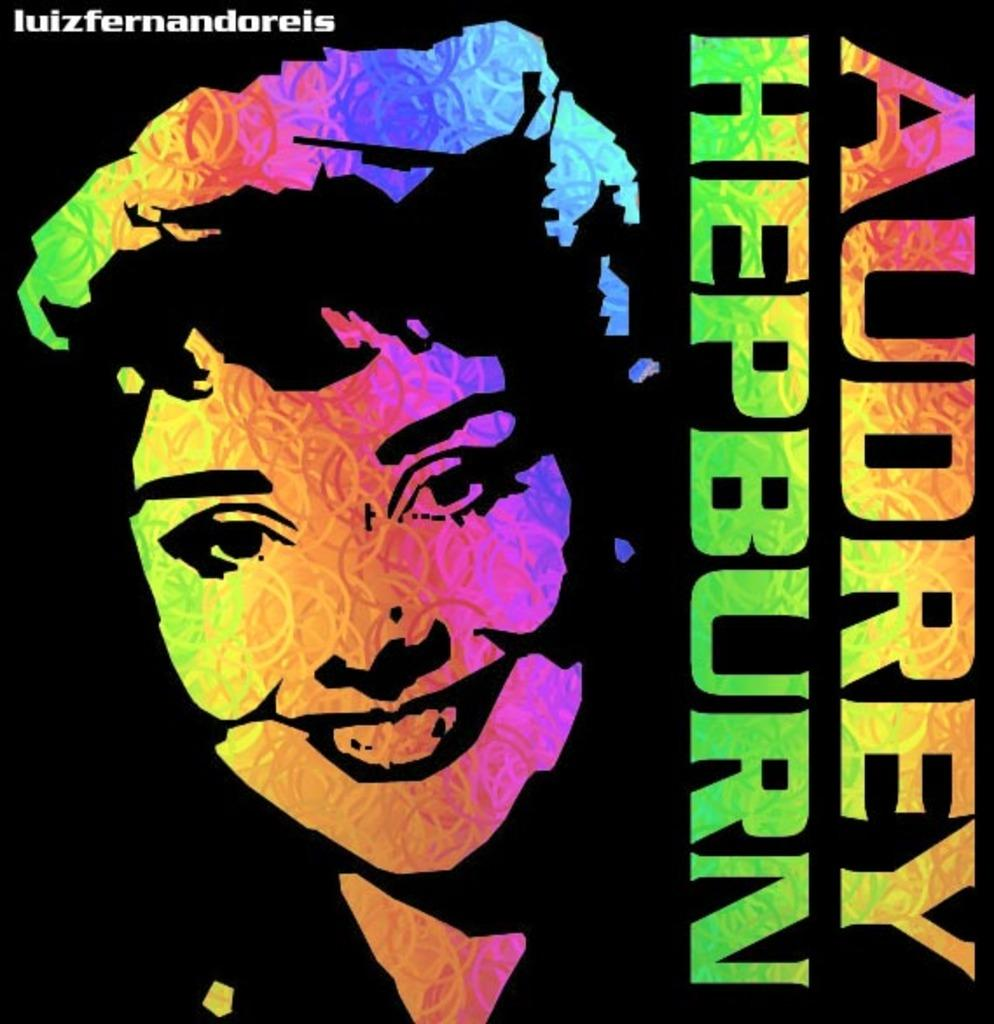What can be said about the nature of the image? The image is edited. What is one of the main subjects in the image? There is a depiction of a person in the image. Are there any words or phrases included in the image? Yes, there is some text present in the image. What type of stem can be seen growing from the person's head in the image? There is no stem growing from the person's head in the image. What is the aftermath of the event depicted in the image? The image does not depict an event, so there is no aftermath to describe. 